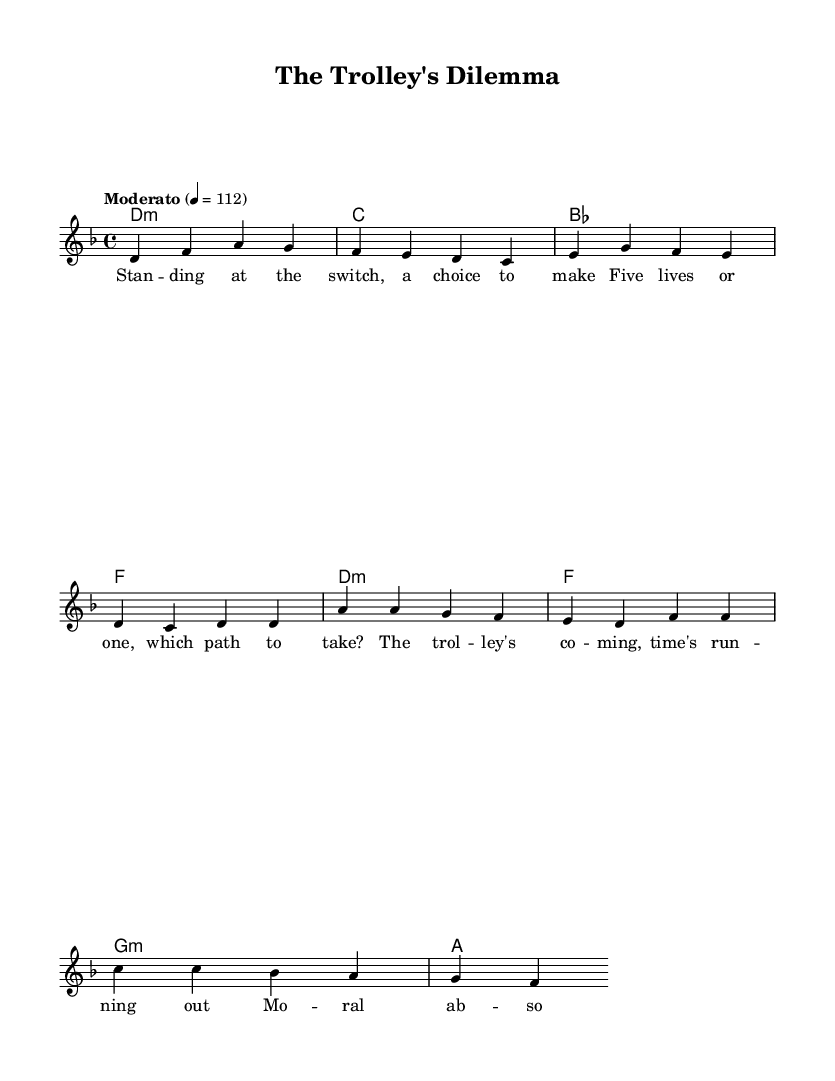What is the key signature of this music? The key signature is indicated at the beginning of the staff, showing two flats, which denotes the key of D minor.
Answer: D minor What is the time signature of this music? The time signature is shown at the beginning, it's 4/4, indicating four beats in a measure.
Answer: 4/4 What is the tempo marking of this piece? The tempo marking indicates the speed of the piece, which is labeled as "Moderato" with a metronome marking of 112 beats per minute.
Answer: Moderato How many measures are in the verse? By counting the measures in the verse section, I see there are four measures of music before it transitions to the chorus.
Answer: Four What is the first lyric of the chorus? The first lyric is found at the start of the chorus section, which reads "The trolley's coming...".
Answer: The trolley's coming Which chord follows the first melody note "d" in the verse? The first melody note "d" is supported by the D minor chord in the chord section, indicating the harmony there.
Answer: D minor What moral dilemma is presented in the lyrics? The lyrics present a moral dilemma about making a life-saving choice, asking whether to save five lives or one, showcasing the ethical conflict.
Answer: Saving five lives or one 